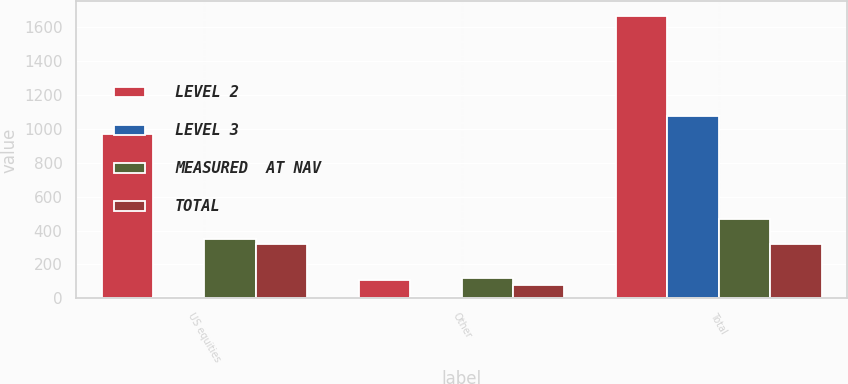Convert chart to OTSL. <chart><loc_0><loc_0><loc_500><loc_500><stacked_bar_chart><ecel><fcel>US equities<fcel>Other<fcel>Total<nl><fcel>LEVEL 2<fcel>968<fcel>107<fcel>1670<nl><fcel>LEVEL 3<fcel>5<fcel>6<fcel>1078<nl><fcel>MEASURED  AT NAV<fcel>350<fcel>121<fcel>471<nl><fcel>TOTAL<fcel>320<fcel>78<fcel>320<nl></chart> 